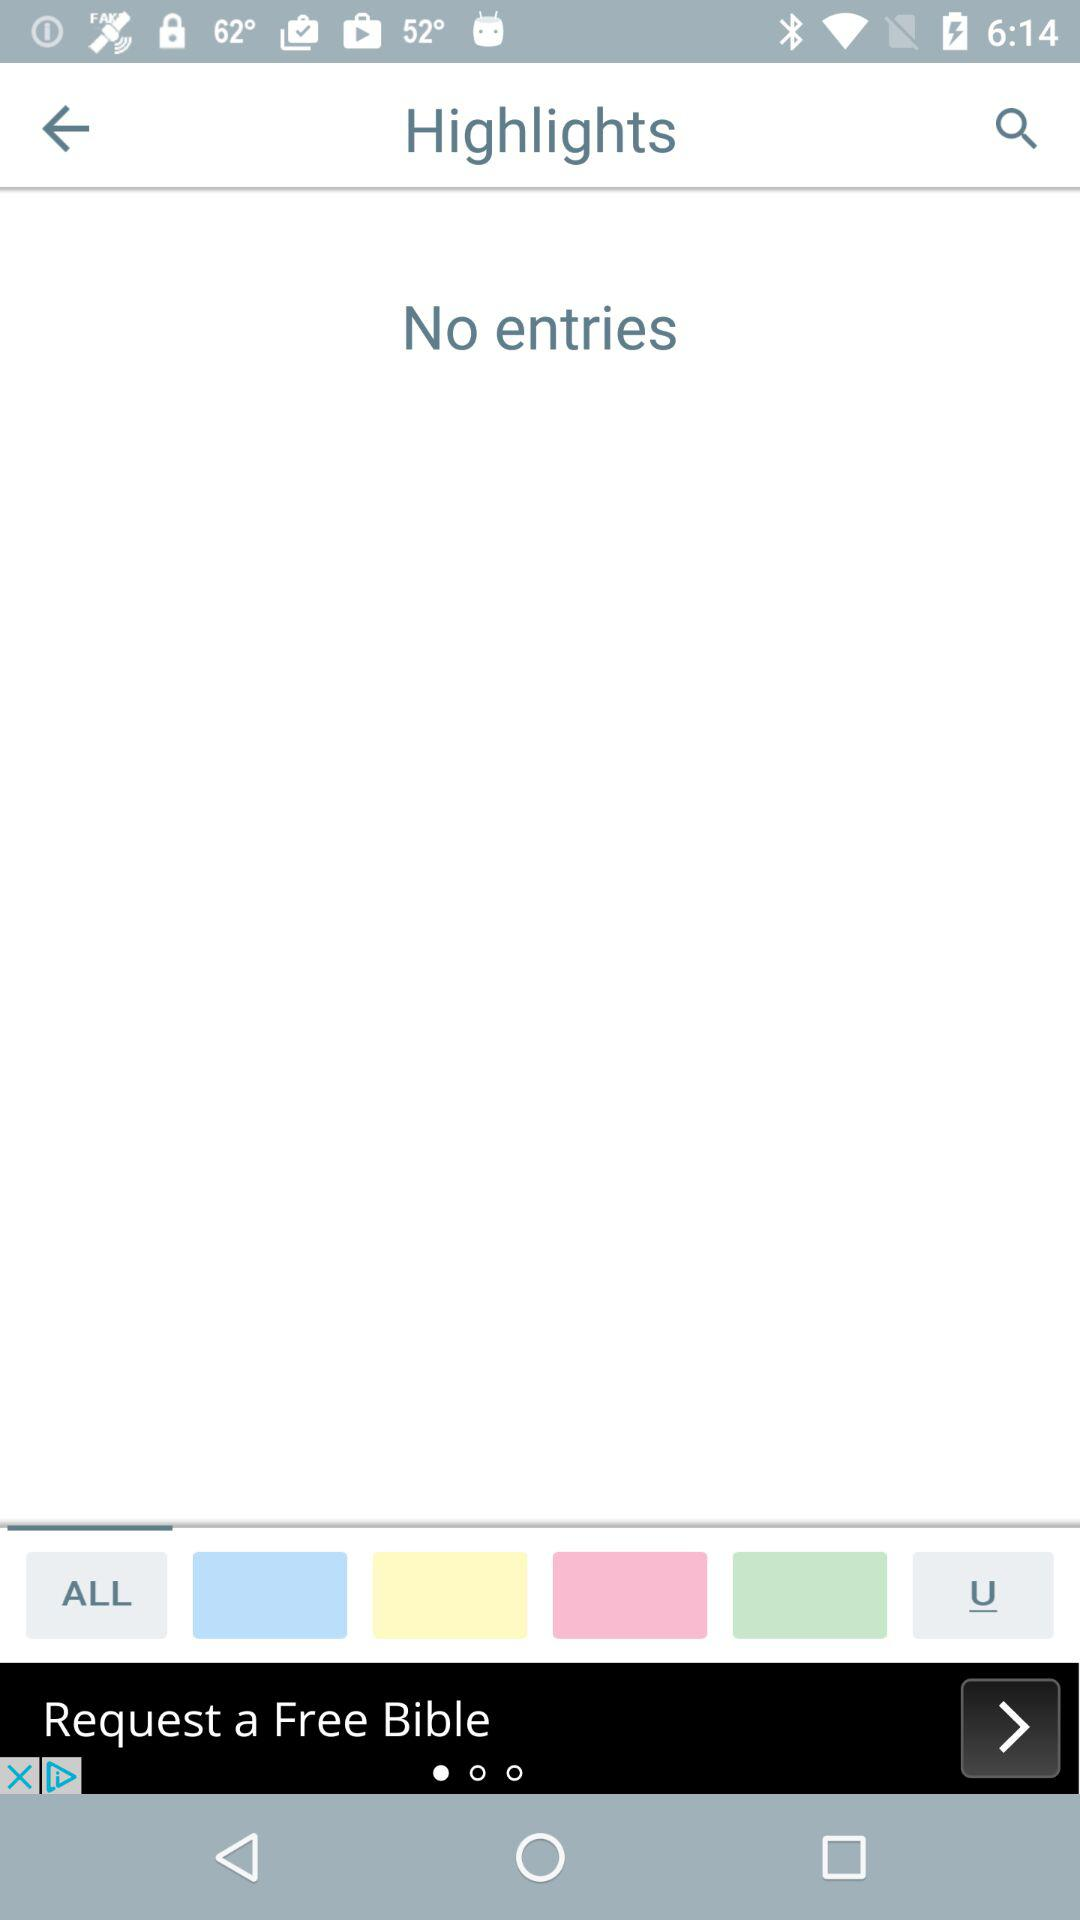Are there any entries? There are no entries. 